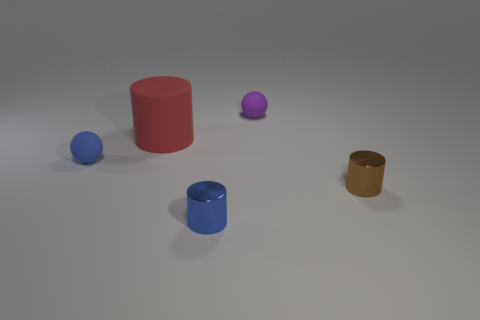Is there anything else that is the same size as the red matte thing?
Make the answer very short. No. Do the brown object and the matte cylinder have the same size?
Your answer should be compact. No. There is a red object that is made of the same material as the tiny blue sphere; what is its size?
Offer a very short reply. Large. There is a cylinder on the left side of the blue object in front of the small ball that is to the left of the large red rubber cylinder; how big is it?
Give a very brief answer. Large. There is a small matte thing in front of the purple thing; does it have the same shape as the purple rubber object?
Make the answer very short. Yes. How many yellow things are rubber objects or big metallic cylinders?
Your response must be concise. 0. Are there more tiny cylinders than big green rubber cylinders?
Your response must be concise. Yes. There is another metallic object that is the same size as the brown object; what color is it?
Provide a succinct answer. Blue. What number of cubes are either big objects or purple objects?
Provide a succinct answer. 0. There is a small brown metal object; is its shape the same as the metallic thing that is left of the tiny purple matte thing?
Ensure brevity in your answer.  Yes. 